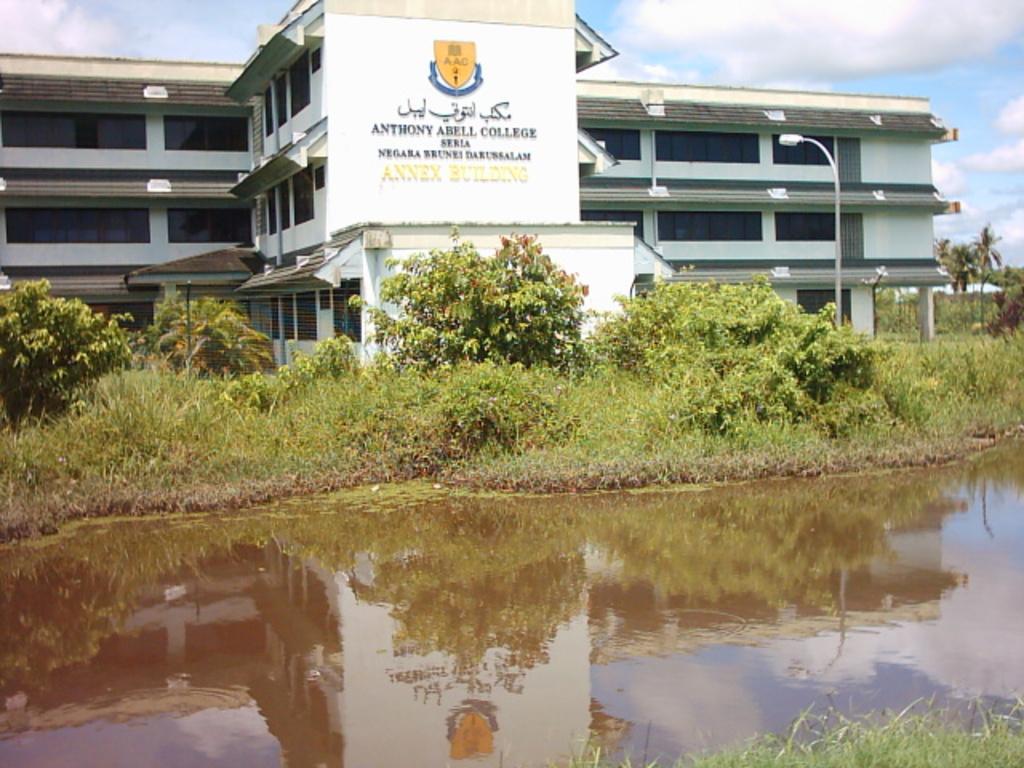What colour is the sheild on the building?
Provide a short and direct response. Answering does not require reading text in the image. 